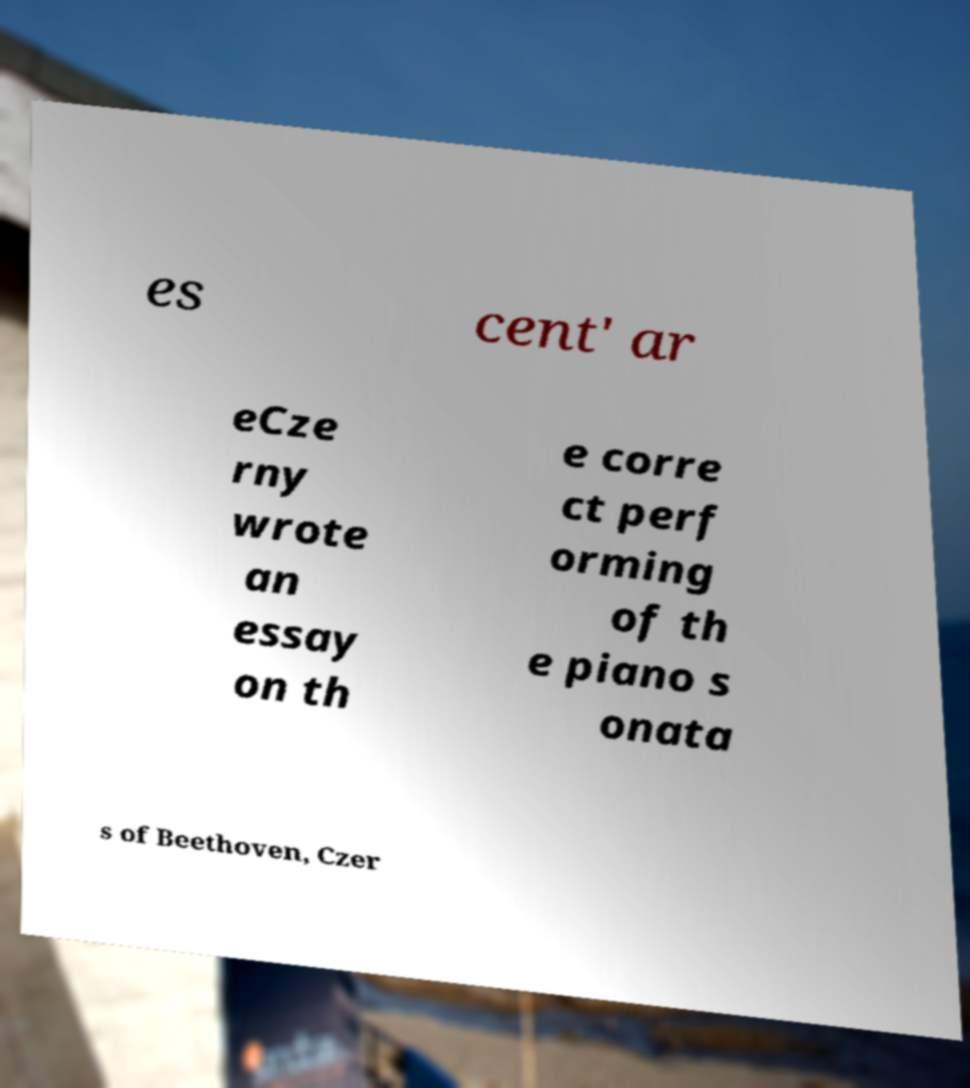Could you extract and type out the text from this image? es cent' ar eCze rny wrote an essay on th e corre ct perf orming of th e piano s onata s of Beethoven, Czer 